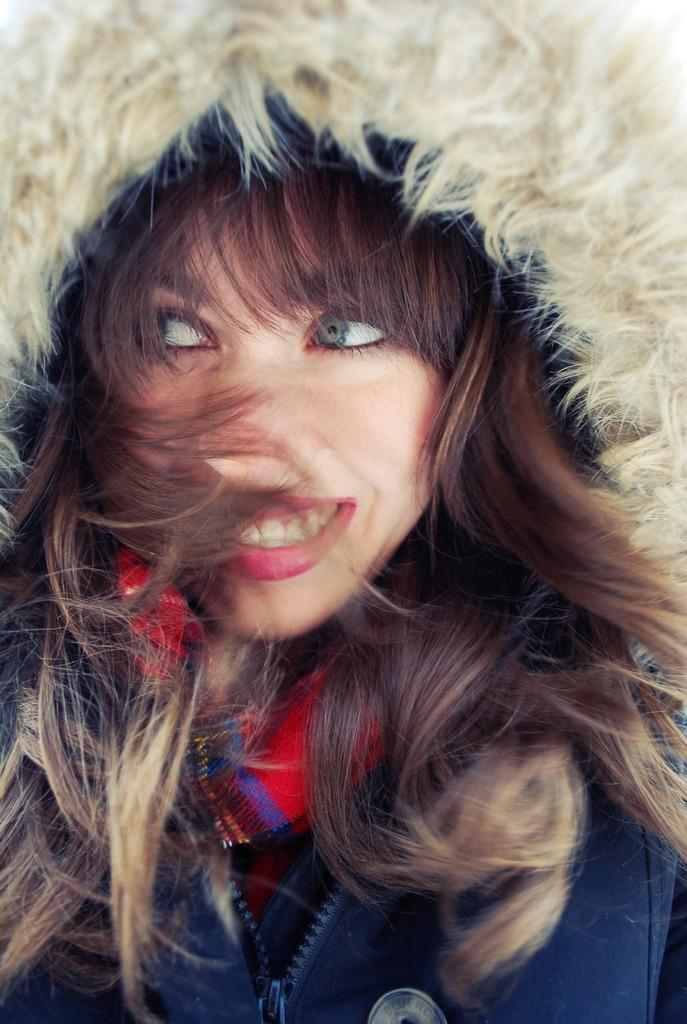What is the main subject of the image? The main subject of the image is a woman. What is the woman sitting on in the image? The woman is sitting on a red stool. What is the woman wearing in the image? The woman is wearing a dark blue jacket. How much does the chicken weigh in the image? There is no chicken present in the image, so its weight cannot be determined. 